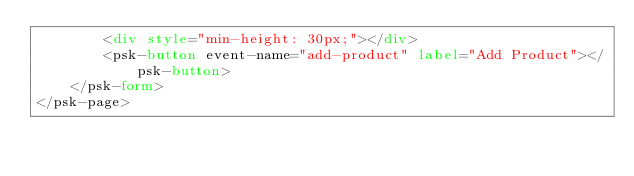<code> <loc_0><loc_0><loc_500><loc_500><_HTML_>        <div style="min-height: 30px;"></div>
        <psk-button event-name="add-product" label="Add Product"></psk-button>
    </psk-form>
</psk-page></code> 